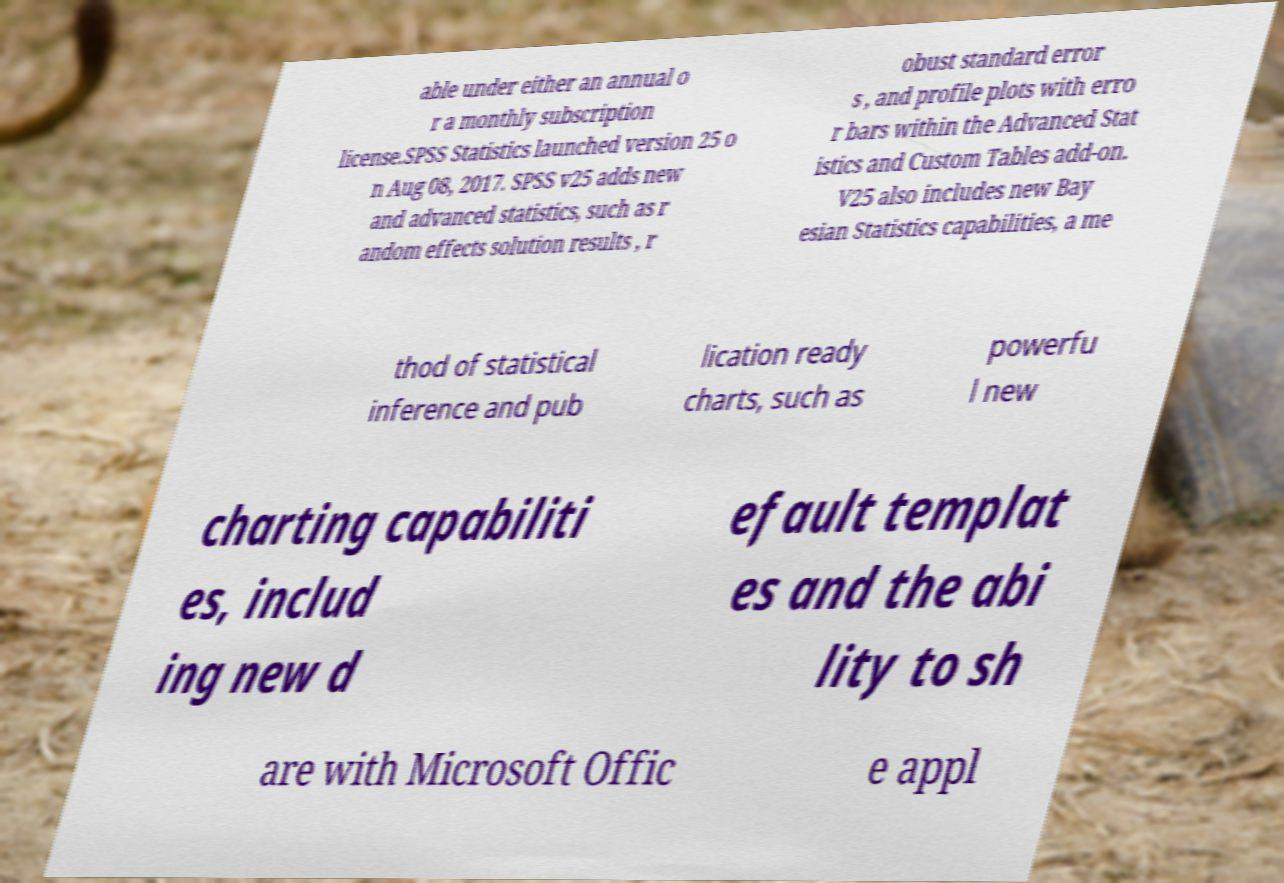Can you read and provide the text displayed in the image?This photo seems to have some interesting text. Can you extract and type it out for me? able under either an annual o r a monthly subscription license.SPSS Statistics launched version 25 o n Aug 08, 2017. SPSS v25 adds new and advanced statistics, such as r andom effects solution results , r obust standard error s , and profile plots with erro r bars within the Advanced Stat istics and Custom Tables add-on. V25 also includes new Bay esian Statistics capabilities, a me thod of statistical inference and pub lication ready charts, such as powerfu l new charting capabiliti es, includ ing new d efault templat es and the abi lity to sh are with Microsoft Offic e appl 